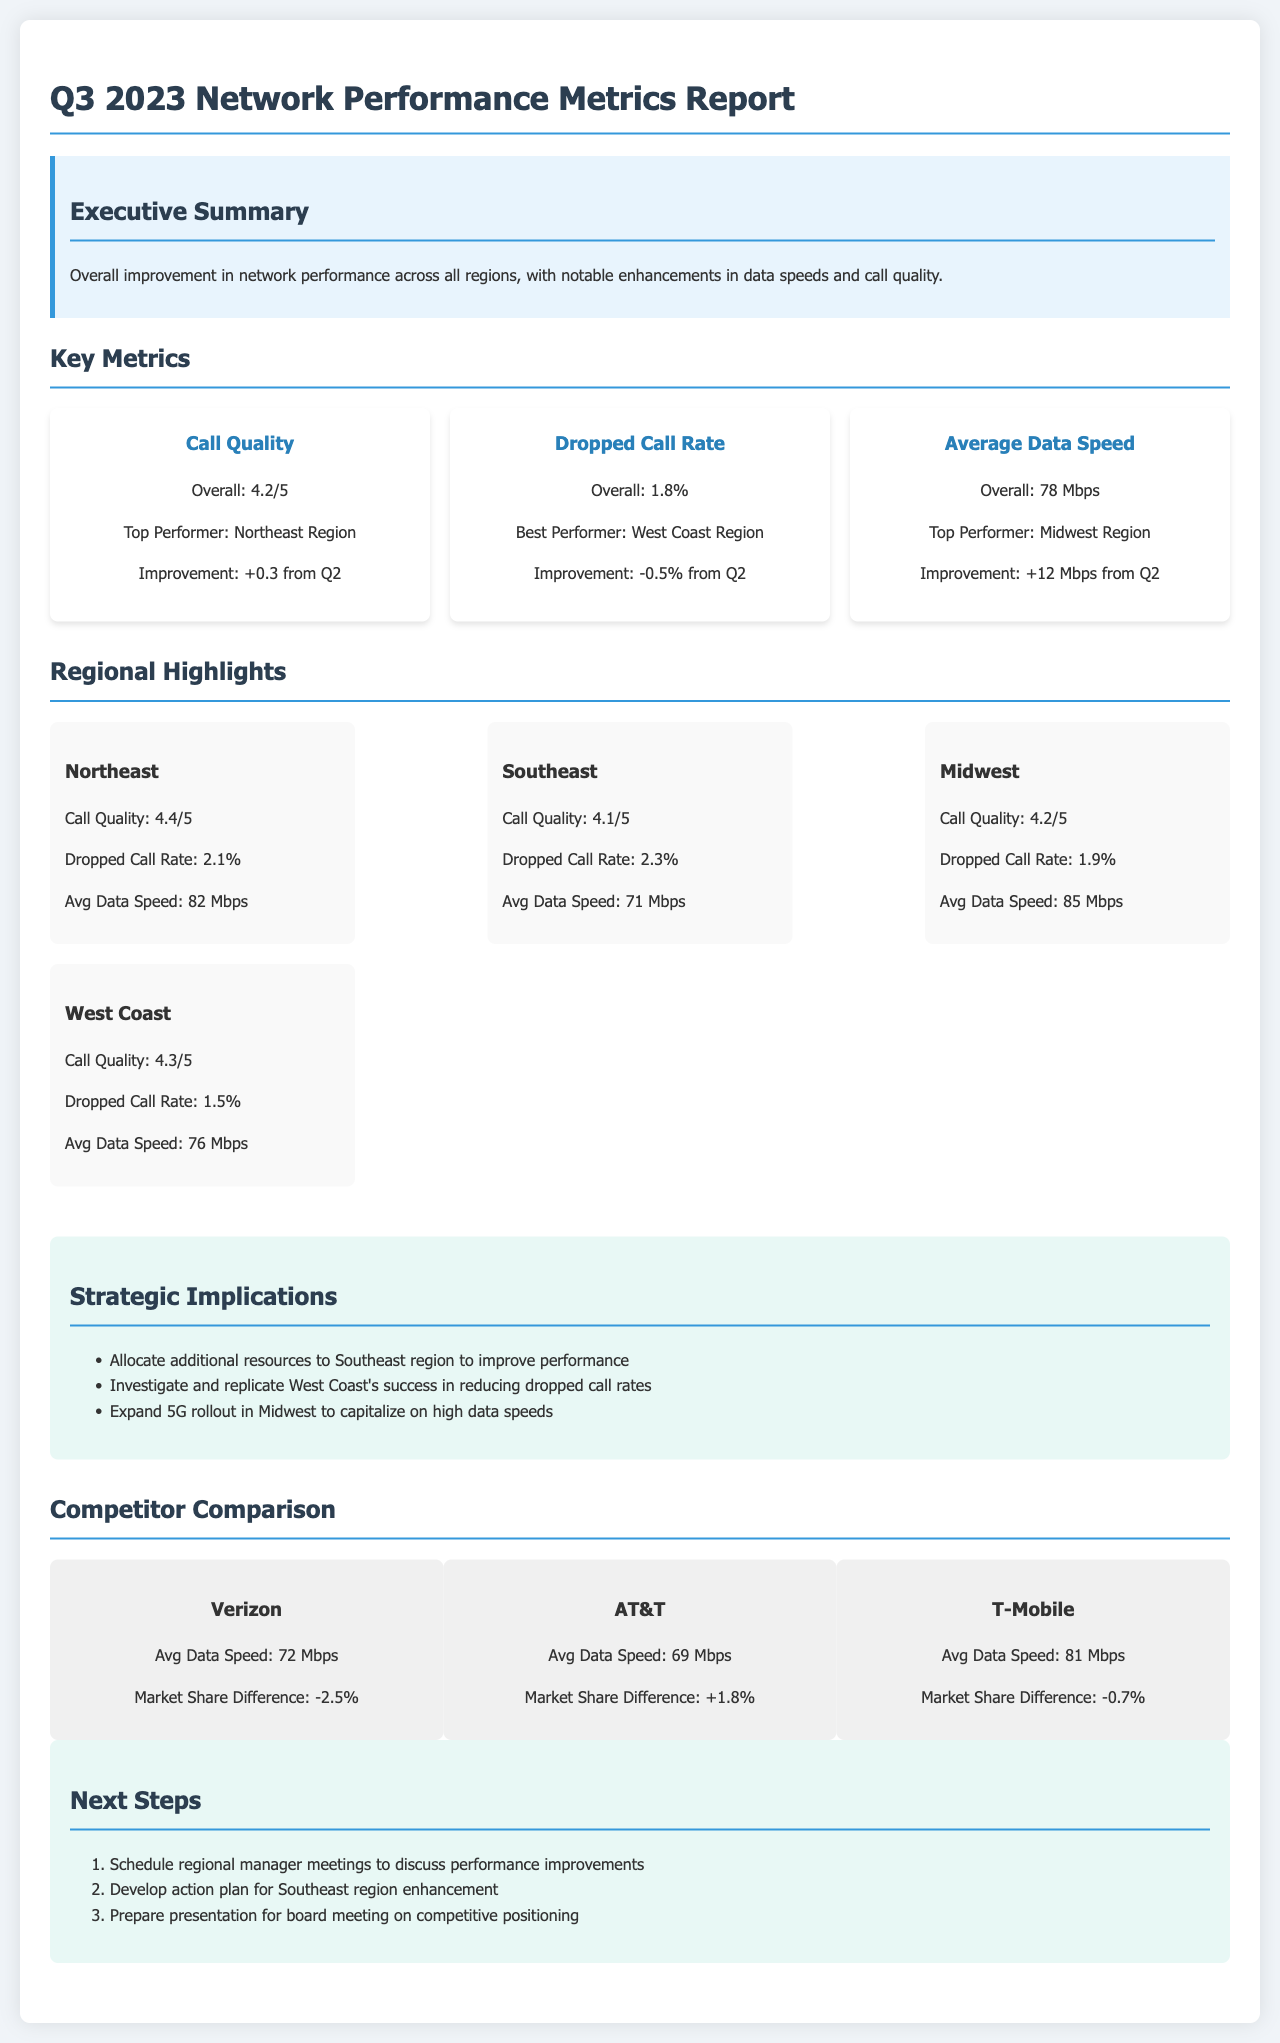What is the overall call quality rating? The overall call quality rating is mentioned in the key metrics section of the report as 4.2 out of 5.
Answer: 4.2/5 Which region has the highest average data speed? The report indicates that the Midwest region has the highest average data speed of 85 Mbps.
Answer: Midwest Region What is the dropped call rate improvement from Q2? The overall dropped call rate improvement from the second quarter is noted as -0.5%.
Answer: -0.5% Which competitor has the highest average data speed? The competitor comparison section shows that T-Mobile has the highest average data speed at 81 Mbps.
Answer: T-Mobile What strategic implication suggests resource allocation? The strategic implications section recommends allocating additional resources to improve the Southeast region's performance.
Answer: Southeast region How much was the average data speed improvement from Q2? The improvement in average data speed from Q2 is detailed as +12 Mbps.
Answer: +12 Mbps What is the best performer in the dropped call rate category? According to the key metrics, the West Coast region is recognized as the best performer in the dropped call rate category.
Answer: West Coast Region What is the call quality rating for the Northeast region? The call quality rating for the Northeast region is specified as 4.4 out of 5.
Answer: 4.4/5 